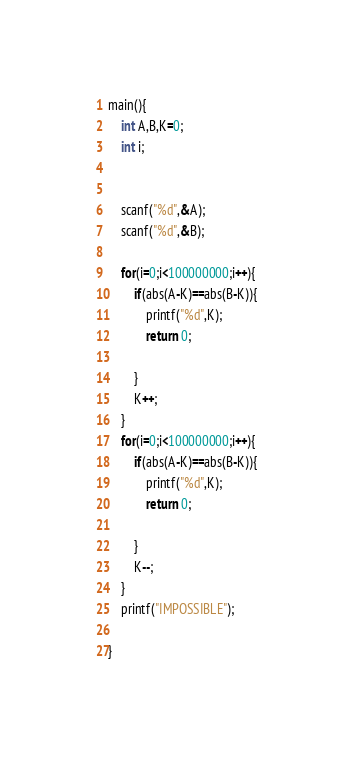<code> <loc_0><loc_0><loc_500><loc_500><_C_>main(){
	int A,B,K=0;
	int i;

	
	scanf("%d",&A);
	scanf("%d",&B);
	
	for(i=0;i<100000000;i++){
		if(abs(A-K)==abs(B-K)){
			printf("%d",K);
			return 0;
			
		}
		K++;
	}
	for(i=0;i<100000000;i++){
		if(abs(A-K)==abs(B-K)){
			printf("%d",K);
			return 0;
			
		}
		K--;
	}
	printf("IMPOSSIBLE");
	
}</code> 